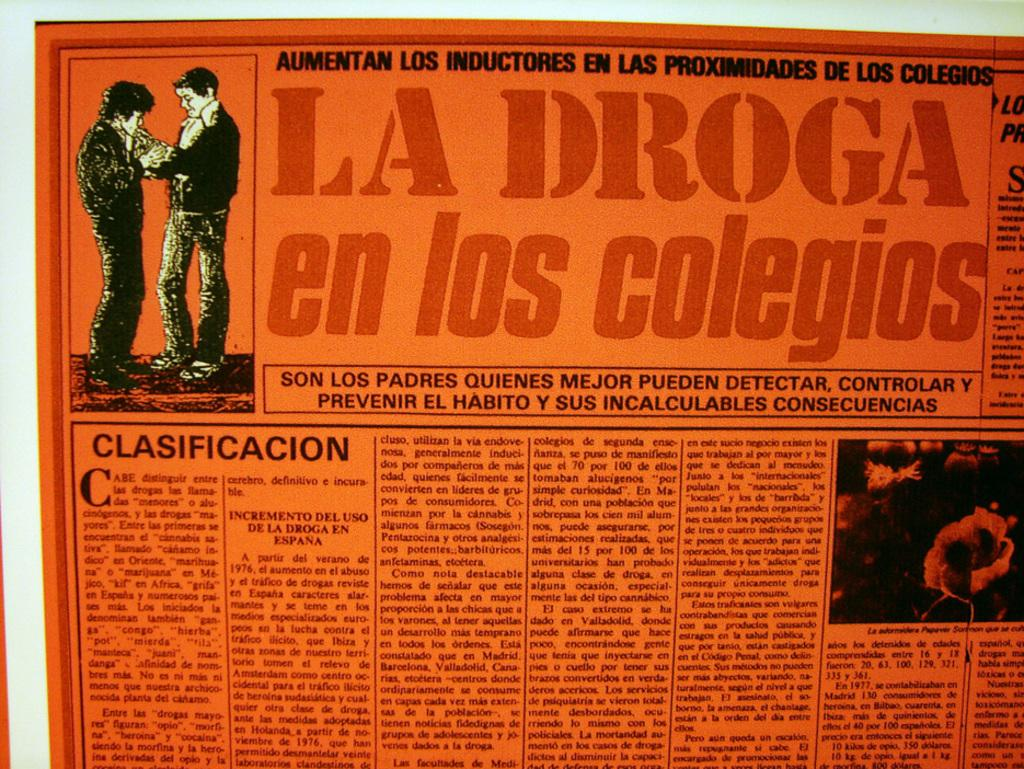What type of image is being described? The image is a poster. What can be found on the poster besides the main image? There is text on the poster. Can you describe the main image on the poster? There are two people holding each other in the top left corner of the poster. What type of spot can be seen on the border of the poster? There is no mention of a spot or border on the poster, so it cannot be determined from the image. 